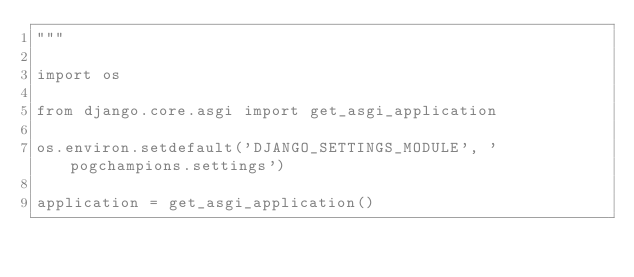Convert code to text. <code><loc_0><loc_0><loc_500><loc_500><_Python_>"""

import os

from django.core.asgi import get_asgi_application

os.environ.setdefault('DJANGO_SETTINGS_MODULE', 'pogchampions.settings')

application = get_asgi_application()
</code> 